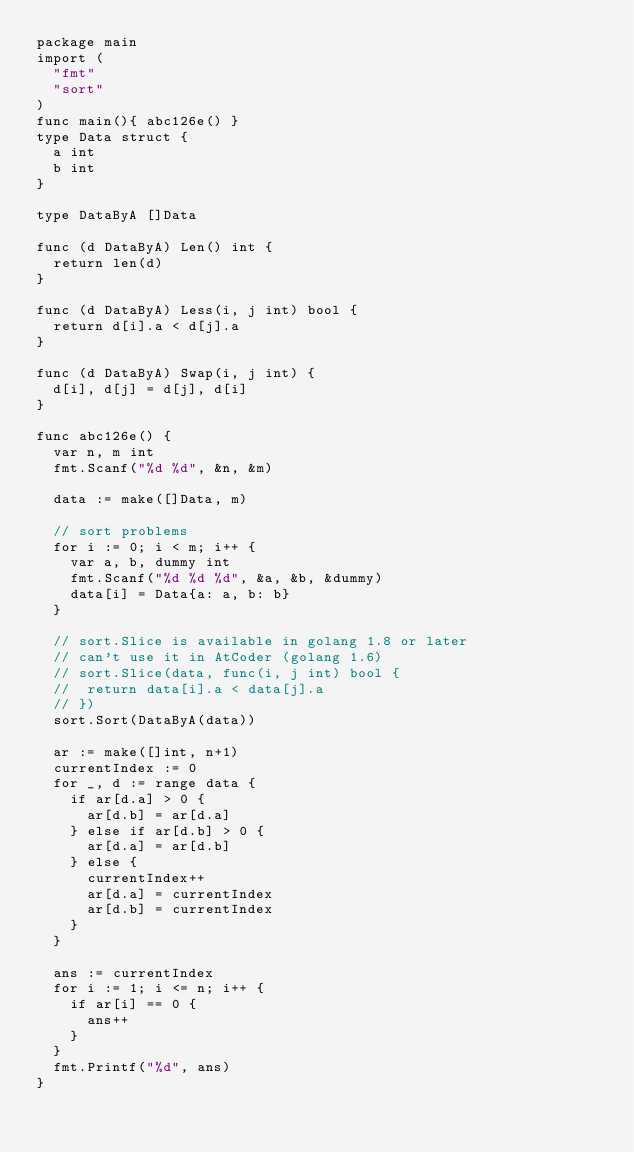<code> <loc_0><loc_0><loc_500><loc_500><_Go_>package main
import (
	"fmt"
	"sort"
)
func main(){ abc126e() }
type Data struct {
	a int
	b int
}

type DataByA []Data

func (d DataByA) Len() int {
	return len(d)
}

func (d DataByA) Less(i, j int) bool {
	return d[i].a < d[j].a
}

func (d DataByA) Swap(i, j int) {
	d[i], d[j] = d[j], d[i]
}

func abc126e() {
	var n, m int
	fmt.Scanf("%d %d", &n, &m)

	data := make([]Data, m)

	// sort problems
	for i := 0; i < m; i++ {
		var a, b, dummy int
		fmt.Scanf("%d %d %d", &a, &b, &dummy)
		data[i] = Data{a: a, b: b}
	}

	// sort.Slice is available in golang 1.8 or later
	// can't use it in AtCoder (golang 1.6)
	// sort.Slice(data, func(i, j int) bool {
	// 	return data[i].a < data[j].a
	// })
	sort.Sort(DataByA(data))

	ar := make([]int, n+1)
	currentIndex := 0
	for _, d := range data {
		if ar[d.a] > 0 {
			ar[d.b] = ar[d.a]
		} else if ar[d.b] > 0 {
			ar[d.a] = ar[d.b]
		} else {
			currentIndex++
			ar[d.a] = currentIndex
			ar[d.b] = currentIndex
		}
	}

	ans := currentIndex
	for i := 1; i <= n; i++ {
		if ar[i] == 0 {
			ans++
		}
	}
	fmt.Printf("%d", ans)
}
</code> 